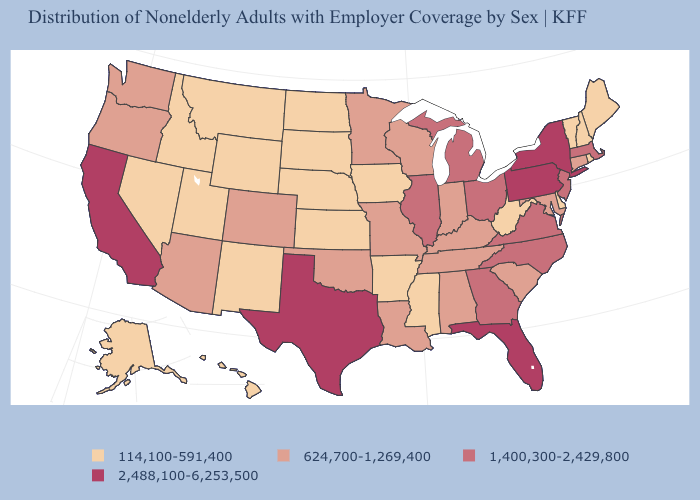Which states have the lowest value in the USA?
Concise answer only. Alaska, Arkansas, Delaware, Hawaii, Idaho, Iowa, Kansas, Maine, Mississippi, Montana, Nebraska, Nevada, New Hampshire, New Mexico, North Dakota, Rhode Island, South Dakota, Utah, Vermont, West Virginia, Wyoming. Does Ohio have the same value as Virginia?
Keep it brief. Yes. Among the states that border Washington , which have the lowest value?
Concise answer only. Idaho. What is the value of Hawaii?
Quick response, please. 114,100-591,400. Which states hav the highest value in the West?
Short answer required. California. What is the value of South Carolina?
Concise answer only. 624,700-1,269,400. How many symbols are there in the legend?
Answer briefly. 4. What is the value of South Dakota?
Quick response, please. 114,100-591,400. Which states hav the highest value in the Northeast?
Quick response, please. New York, Pennsylvania. What is the value of Tennessee?
Concise answer only. 624,700-1,269,400. Does the map have missing data?
Concise answer only. No. Among the states that border Missouri , which have the lowest value?
Quick response, please. Arkansas, Iowa, Kansas, Nebraska. Which states hav the highest value in the West?
Quick response, please. California. What is the lowest value in states that border Connecticut?
Write a very short answer. 114,100-591,400. What is the highest value in the Northeast ?
Be succinct. 2,488,100-6,253,500. 